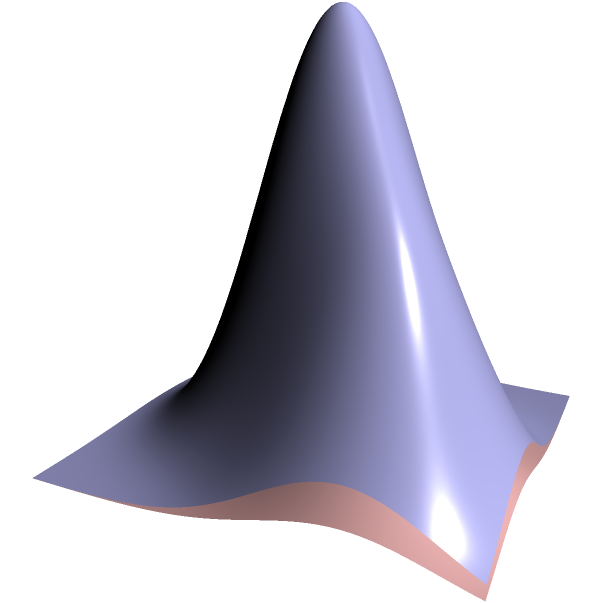In protein folding research, you encounter a complex 3D structure represented by the graph above. The blue surface shows the initial protein conformation, while the red surface represents a potential folded state. If the protein must traverse from the highest peak of the blue surface to the lowest point of the red surface, what is the minimum number of intermediate conformational changes required, assuming each change can only modify one dimension at a time? To solve this problem, we need to analyze the 3D structure step-by-step:

1. Identify the highest peak of the blue surface:
   - Located at approximately (0, 0, 2)

2. Identify the lowest point of the red surface:
   - Located at approximately (0, 0, 0.5)

3. Analyze the required changes:
   a. Z-axis change: From 2 to 0.5
   b. X-axis change: No change required (both at 0)
   c. Y-axis change: No change required (both at 0)

4. Count the minimum number of changes:
   - Only one change is required along the Z-axis
   - No changes are needed for X and Y axes

5. Consider the constraint of one-dimensional changes:
   - The single Z-axis change satisfies this constraint

Therefore, the minimum number of intermediate conformational changes required is 1, as we only need to modify the Z-axis position from 2 to 0.5.
Answer: 1 